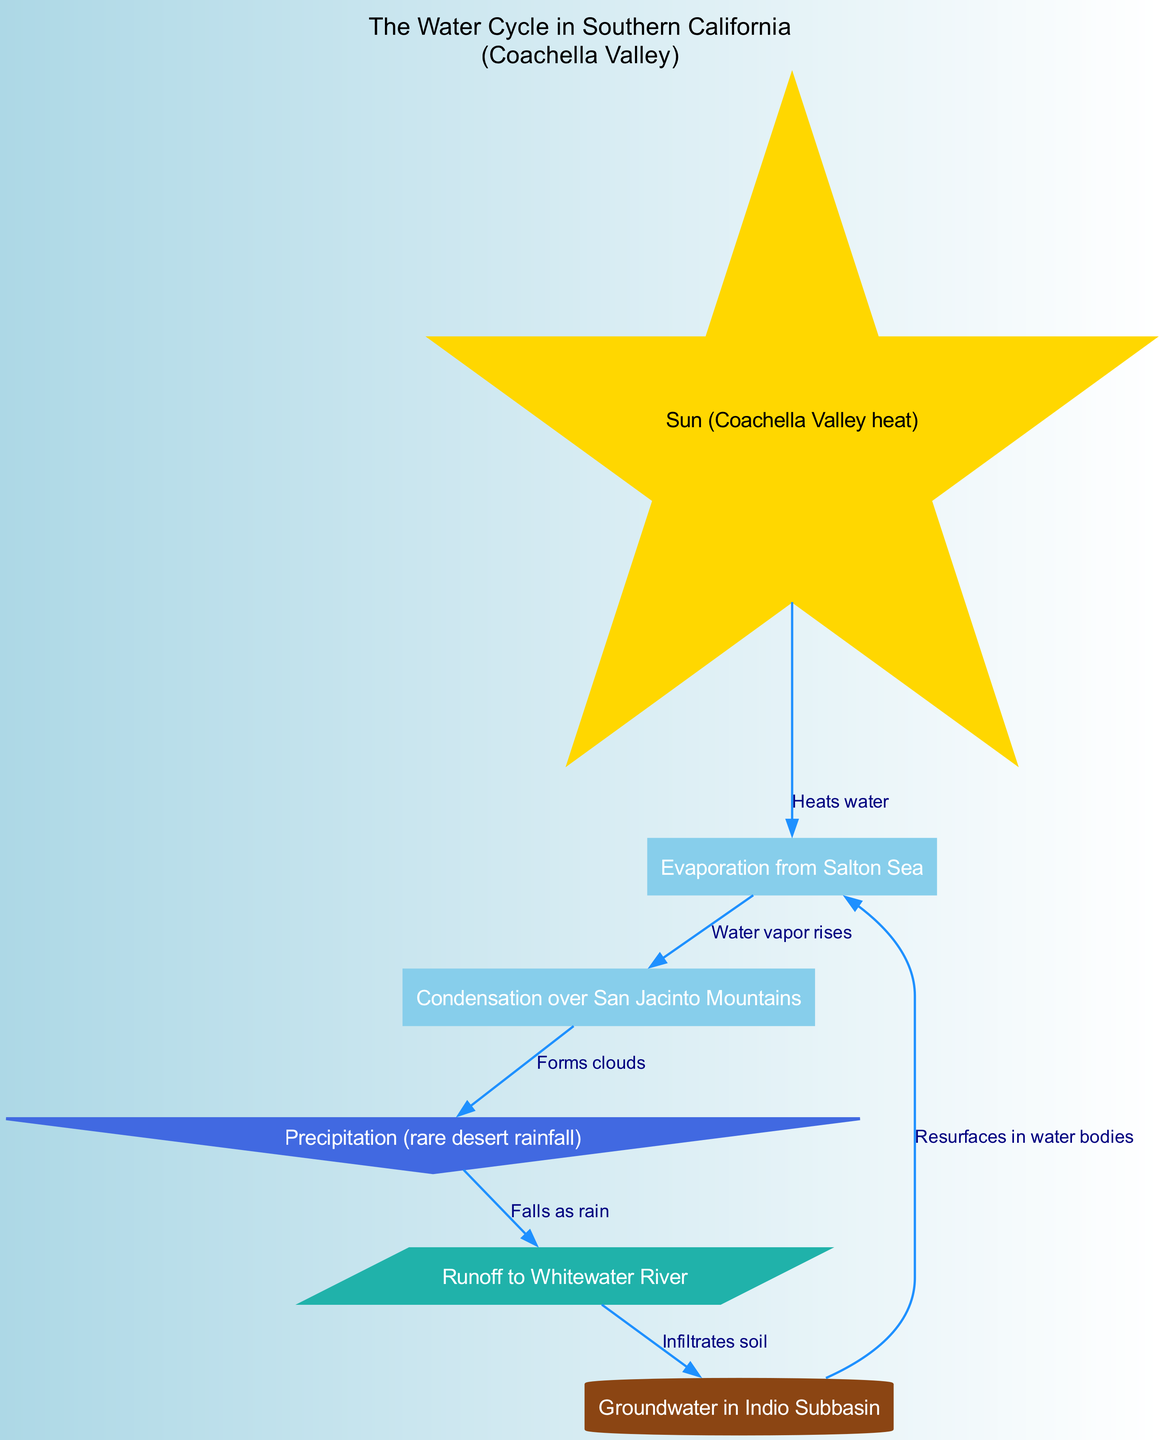What is the main source of heat for evaporation in the water cycle? The diagram indicates that the Sun, specifically referring to Coachella Valley heat, is the main source of heat that drives evaporation from water bodies.
Answer: Sun (Coachella Valley heat) How many nodes are present in the diagram? By counting the distinct labeled entities in the diagram, we find there are six nodes, namely: Sun, Evaporation, Condensation, Precipitation, Runoff, and Groundwater.
Answer: 6 What process occurs after condensation in the water cycle? From the diagram, it is shown that after condensation, the next step is precipitation where clouds form and then release rain.
Answer: Precipitation (rare desert rainfall) What does runoff lead to in the water cycle? According to the diagram, runoff leads to groundwater as it infiltrates the soil after rainfall.
Answer: Groundwater in Indio Subbasin Which node is represented by a star in the diagram? The diagram specifically distinguishes the main source of heat by representing the Sun with a star shape, indicating its importance in the water cycle.
Answer: Sun (Coachella Valley heat) What type of relationship exists between evaporation and condensation? The diagram illustrates a direct relationship where evaporation leads to condensation, indicating that water vapor rises and cools to form clouds.
Answer: Water vapor rises What shape represents precipitation in the diagram? In the diagram, precipitation is represented by an inverted triangle shape, which uniquely identifies it from other processes.
Answer: Inverted triangle What element resurfaces in water bodies as part of the water cycle? The flow of the diagram indicates that groundwater resurfaces in water bodies, contributing back to evaporation processes.
Answer: Resurfaces in water bodies How does groundwater contribute to the water cycle? According to the diagram, groundwater re-enters the water cycle by resurfacing and contributing to evaporation, thus continuing the cycle of water movement.
Answer: Resurfaces in water bodies 